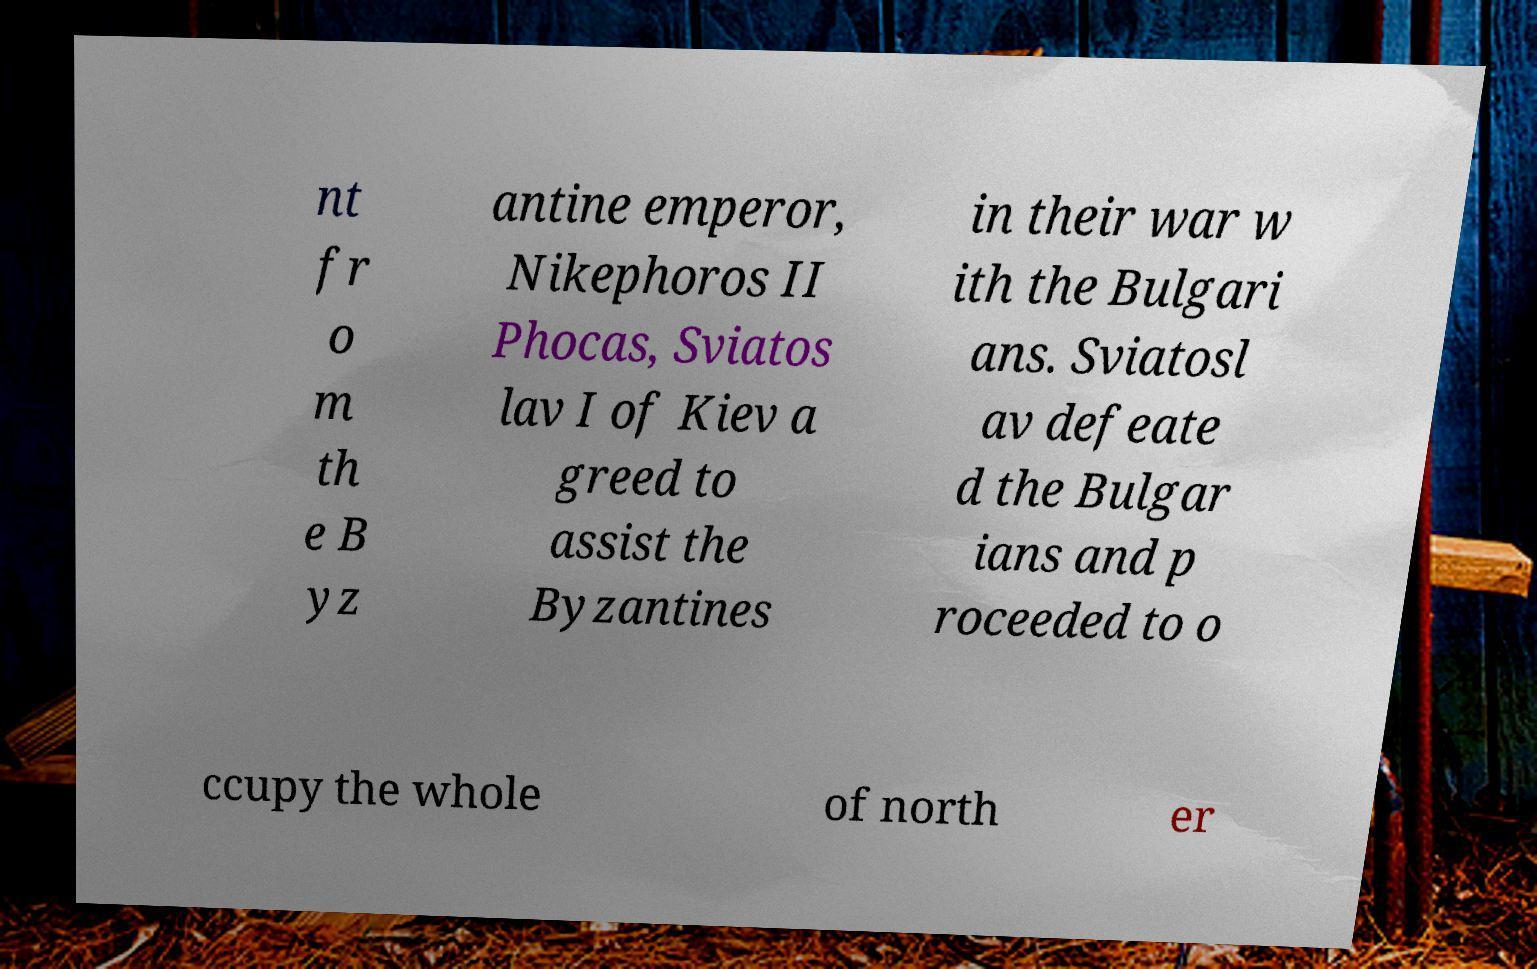Can you read and provide the text displayed in the image?This photo seems to have some interesting text. Can you extract and type it out for me? nt fr o m th e B yz antine emperor, Nikephoros II Phocas, Sviatos lav I of Kiev a greed to assist the Byzantines in their war w ith the Bulgari ans. Sviatosl av defeate d the Bulgar ians and p roceeded to o ccupy the whole of north er 